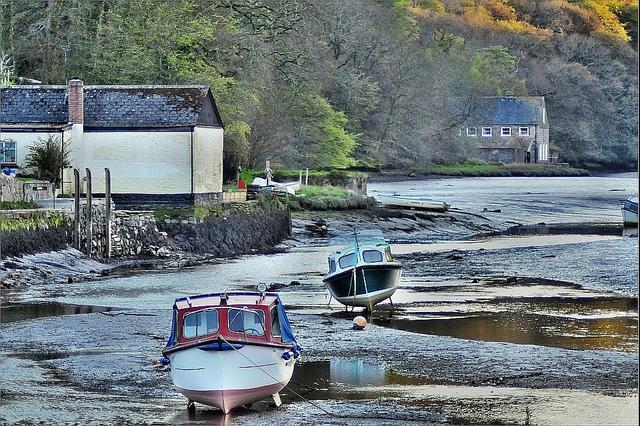What shape is the item on the floor that is in front of the boat that is behind the red boat?
Make your selection from the four choices given to correctly answer the question.
Options: Square, rectangle, rhombus, round. Round. 